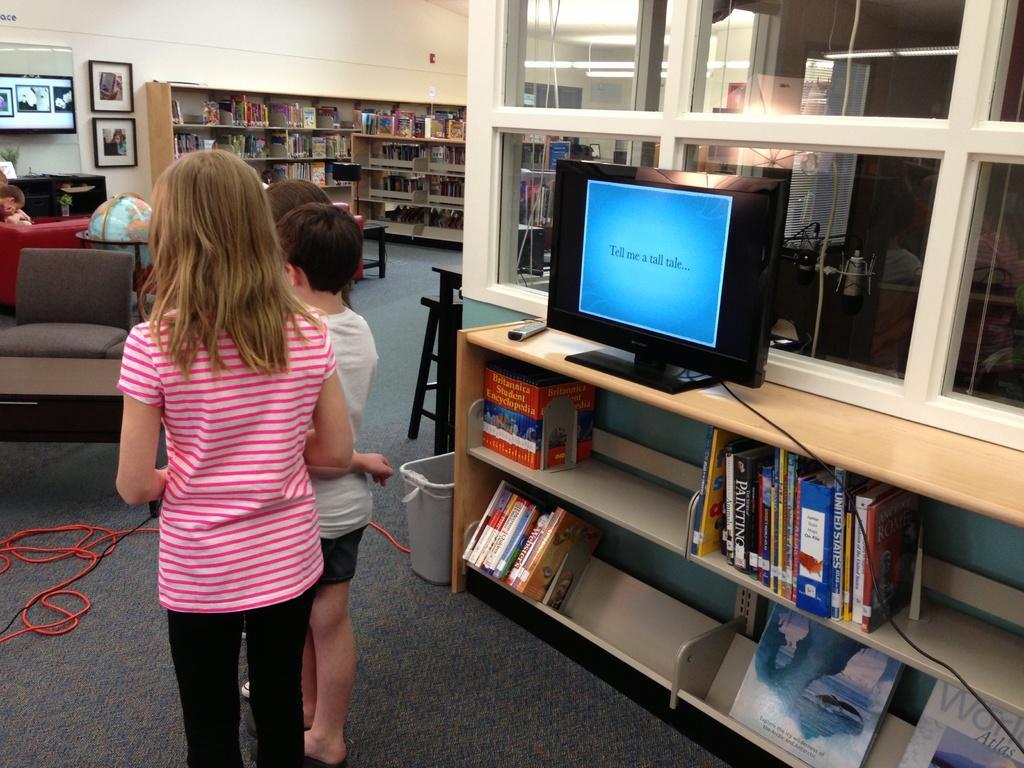In one or two sentences, can you explain what this image depicts? In this image, There is a floor which is in black color, In the left side there are some kids standing, In the right side there is a table which is in yellow color on that table there is a monitor which is in black color, There are some books kept in racks, There is a sofa in ash color, There are some books kept in the shelf and there is a white color wall in the background. 